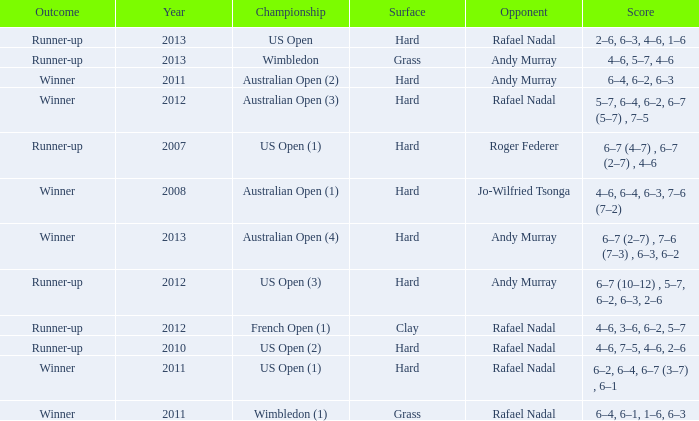What is the outcome of the 4–6, 6–4, 6–3, 7–6 (7–2) score? Winner. 